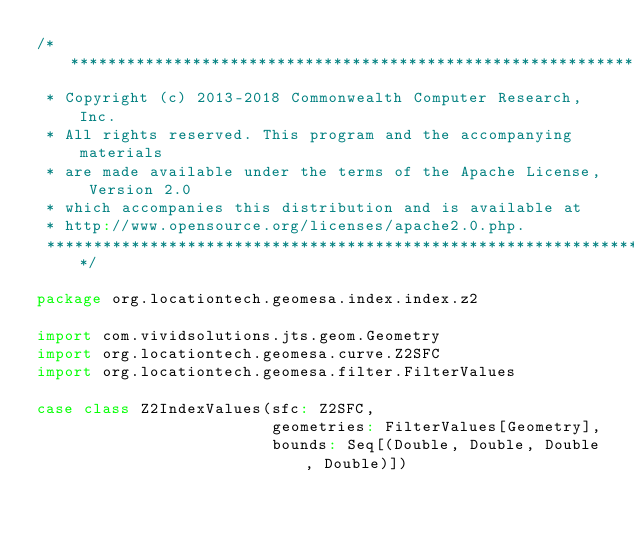<code> <loc_0><loc_0><loc_500><loc_500><_Scala_>/***********************************************************************
 * Copyright (c) 2013-2018 Commonwealth Computer Research, Inc.
 * All rights reserved. This program and the accompanying materials
 * are made available under the terms of the Apache License, Version 2.0
 * which accompanies this distribution and is available at
 * http://www.opensource.org/licenses/apache2.0.php.
 ***********************************************************************/

package org.locationtech.geomesa.index.index.z2

import com.vividsolutions.jts.geom.Geometry
import org.locationtech.geomesa.curve.Z2SFC
import org.locationtech.geomesa.filter.FilterValues

case class Z2IndexValues(sfc: Z2SFC,
                         geometries: FilterValues[Geometry],
                         bounds: Seq[(Double, Double, Double, Double)])
</code> 